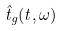Convert formula to latex. <formula><loc_0><loc_0><loc_500><loc_500>\hat { t } _ { g } ( t , \omega )</formula> 